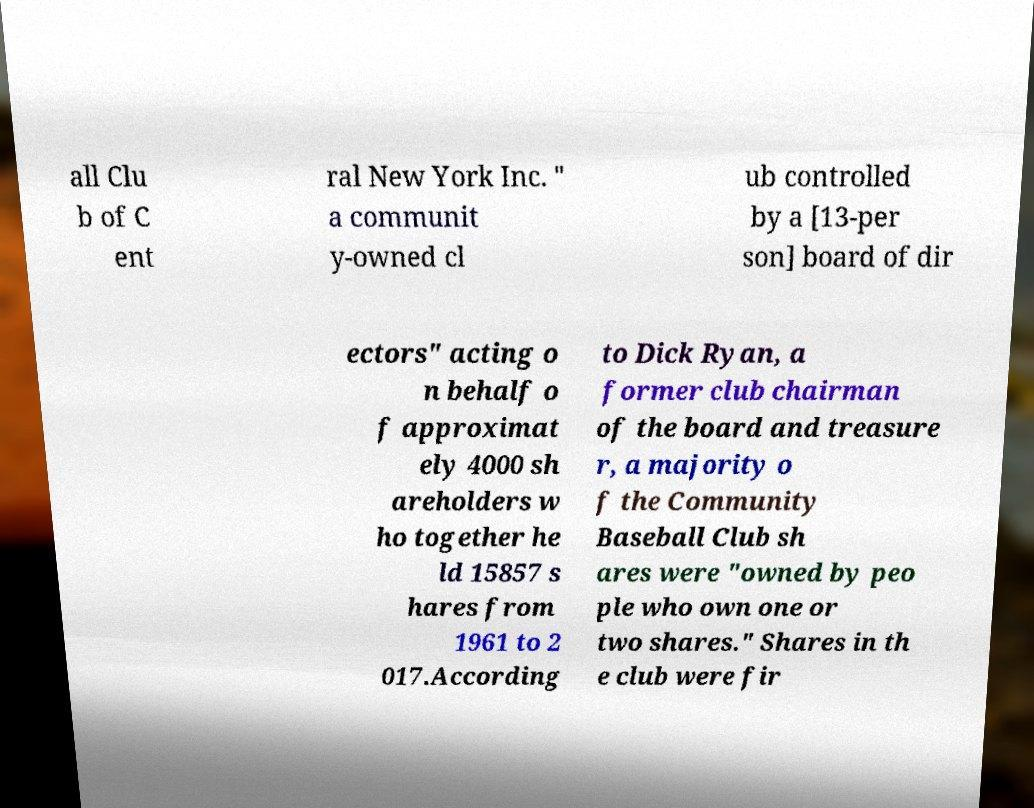Can you accurately transcribe the text from the provided image for me? all Clu b of C ent ral New York Inc. " a communit y-owned cl ub controlled by a [13-per son] board of dir ectors" acting o n behalf o f approximat ely 4000 sh areholders w ho together he ld 15857 s hares from 1961 to 2 017.According to Dick Ryan, a former club chairman of the board and treasure r, a majority o f the Community Baseball Club sh ares were "owned by peo ple who own one or two shares." Shares in th e club were fir 